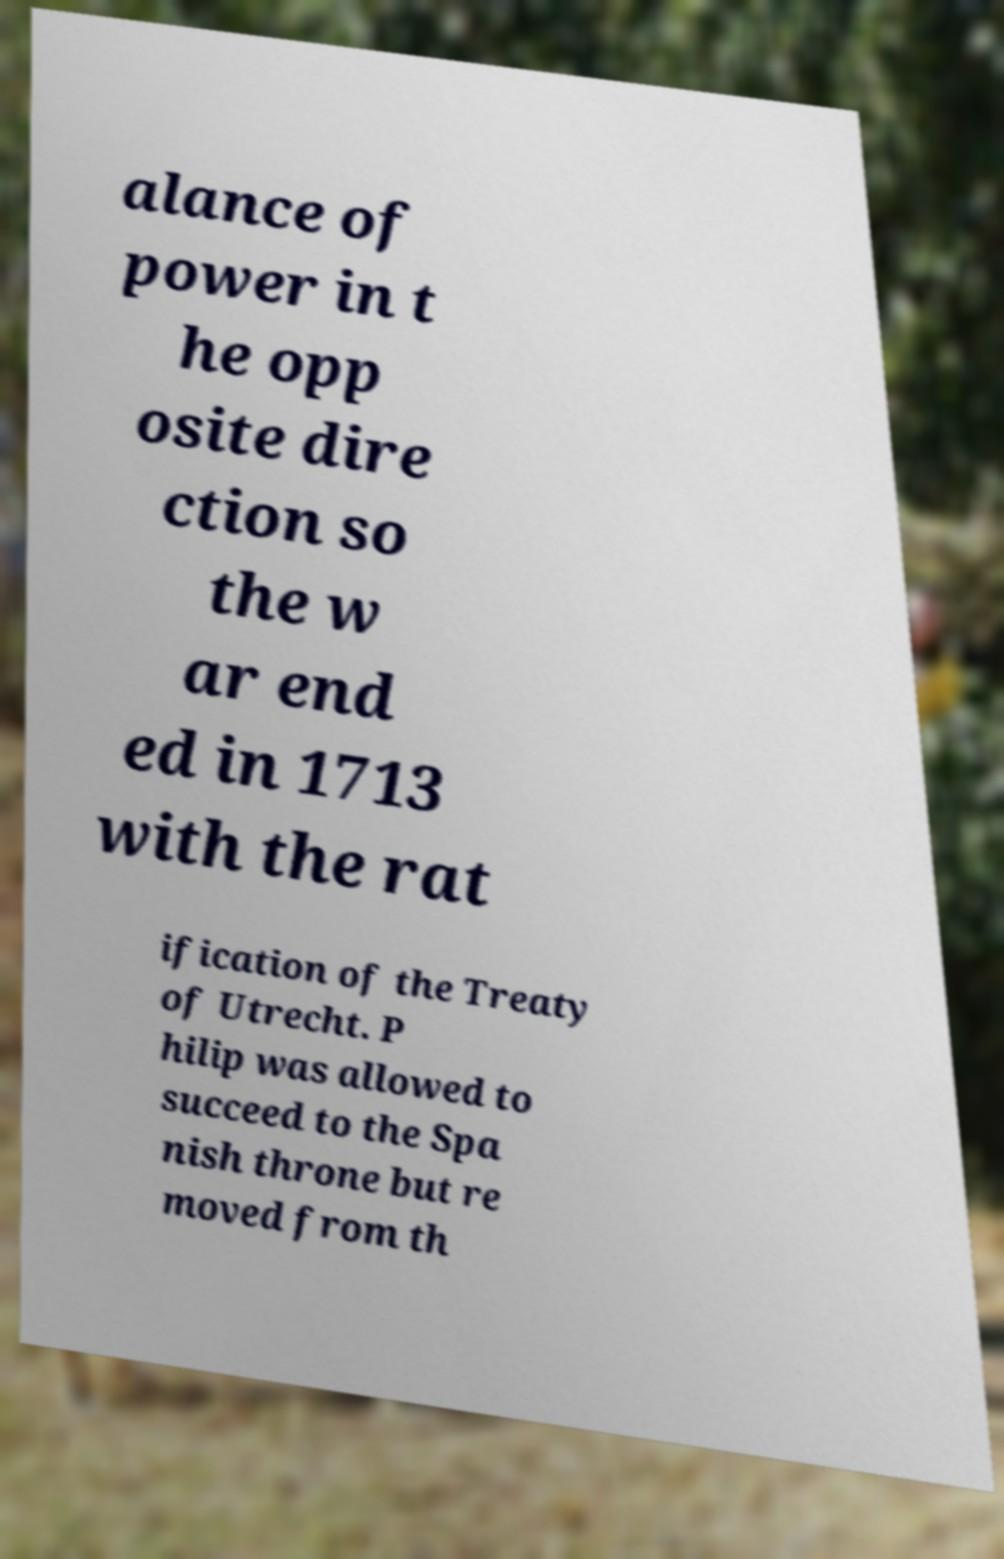Please identify and transcribe the text found in this image. alance of power in t he opp osite dire ction so the w ar end ed in 1713 with the rat ification of the Treaty of Utrecht. P hilip was allowed to succeed to the Spa nish throne but re moved from th 